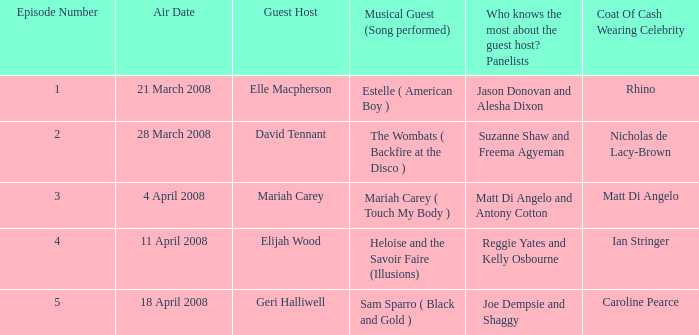Name the number of panelists for oat of cash wearing celebrity being matt di angelo 1.0. 